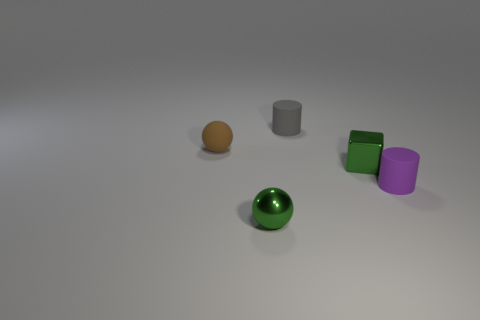Add 3 green objects. How many objects exist? 8 Subtract all blocks. How many objects are left? 4 Add 5 blue metallic things. How many blue metallic things exist? 5 Subtract 0 green cylinders. How many objects are left? 5 Subtract all shiny things. Subtract all brown matte balls. How many objects are left? 2 Add 3 tiny matte spheres. How many tiny matte spheres are left? 4 